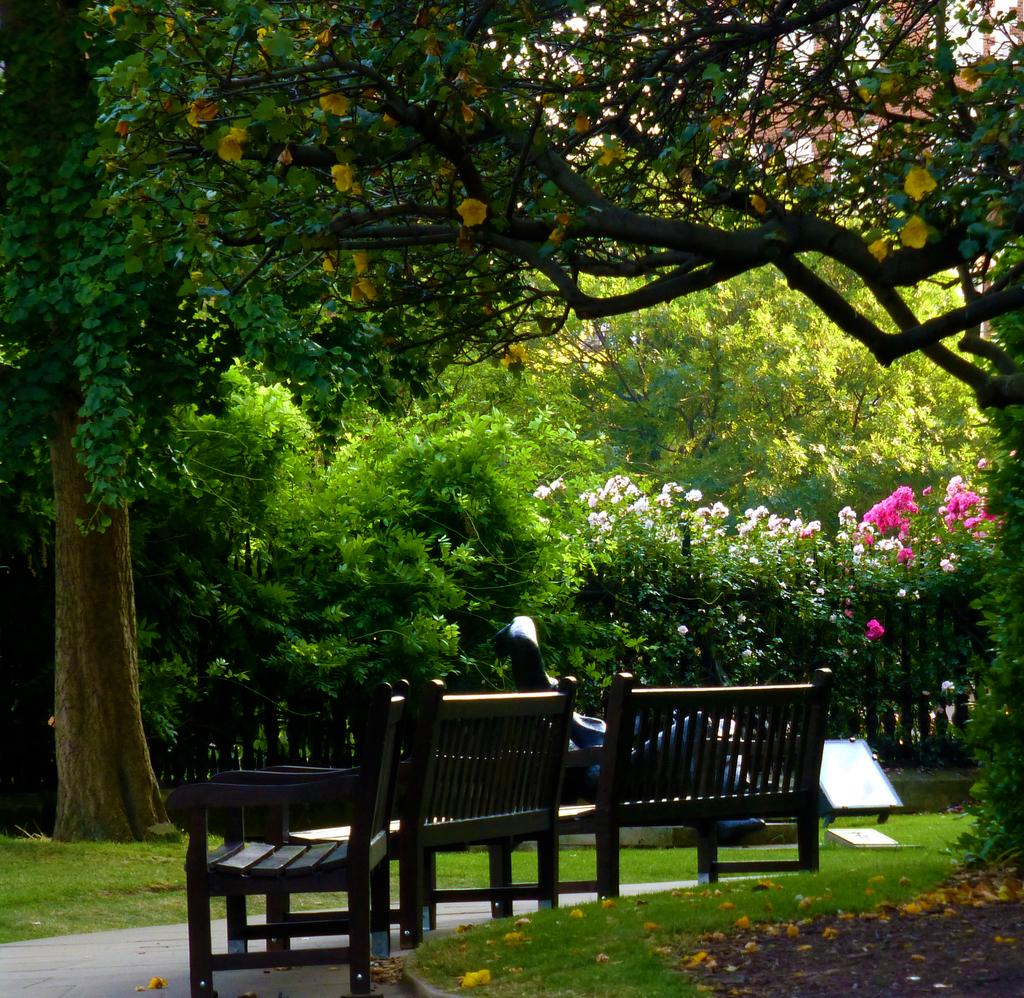What type of outdoor space is depicted in the image? There is a garden in the image. What can be seen among the trees in the garden? The garden is covered with beautiful trees. What other types of vegetation are present in the garden? The garden has plants. How many seating options are available in the garden? There are two benches and one wooden chair in the garden. What type of throat medicine is visible on the wooden chair in the garden? There is no throat medicine present in the image; it features a garden with trees, plants, and seating options. 